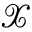<formula> <loc_0><loc_0><loc_500><loc_500>\mathcal { X }</formula> 